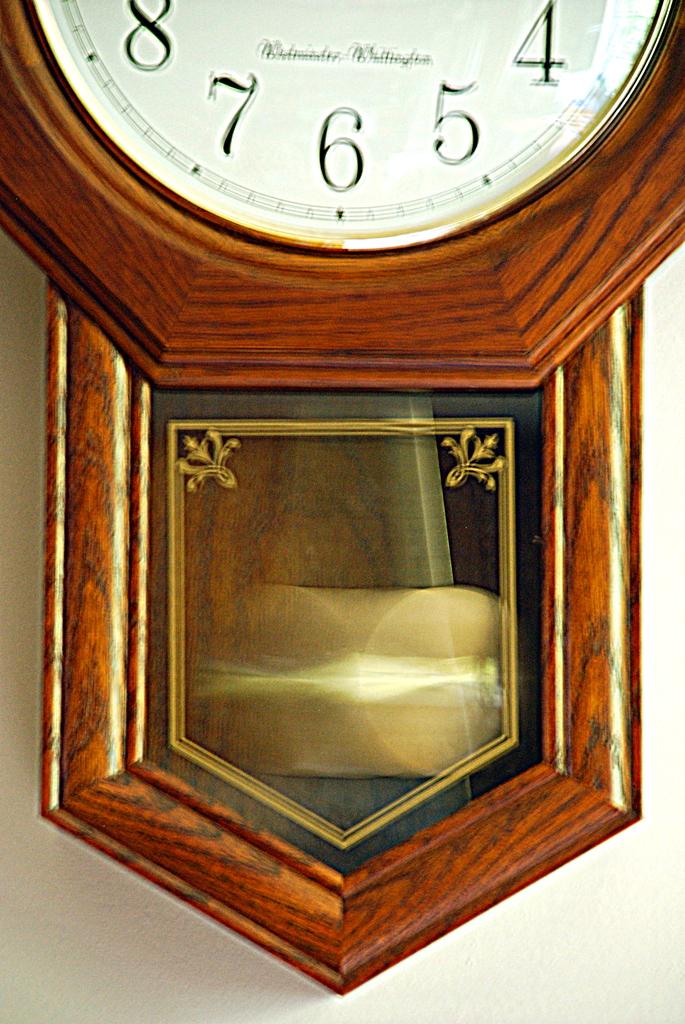What number is at the bottom of the clock?
Provide a short and direct response. 6. 